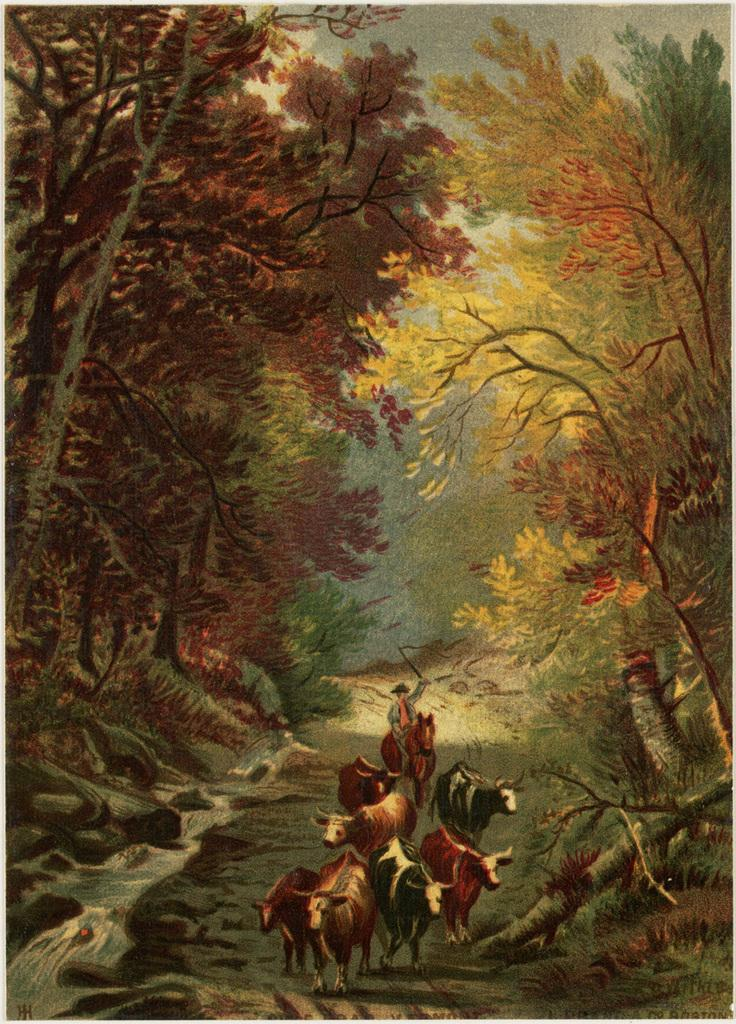What is the main subject of the image? The image contains a painting. What is depicted in the painting? The painting depicts animals, a person wearing clothes and a cap, trees, grass, water, and a sky. Can you describe the person in the painting? The person in the painting is wearing clothes and a cap. What type of education is the person in the painting pursuing? There is no indication in the image or painting that the person is pursuing any type of education. What kind of trouble is the person in the painting facing? There is no indication in the image or painting that the person is facing any trouble. 